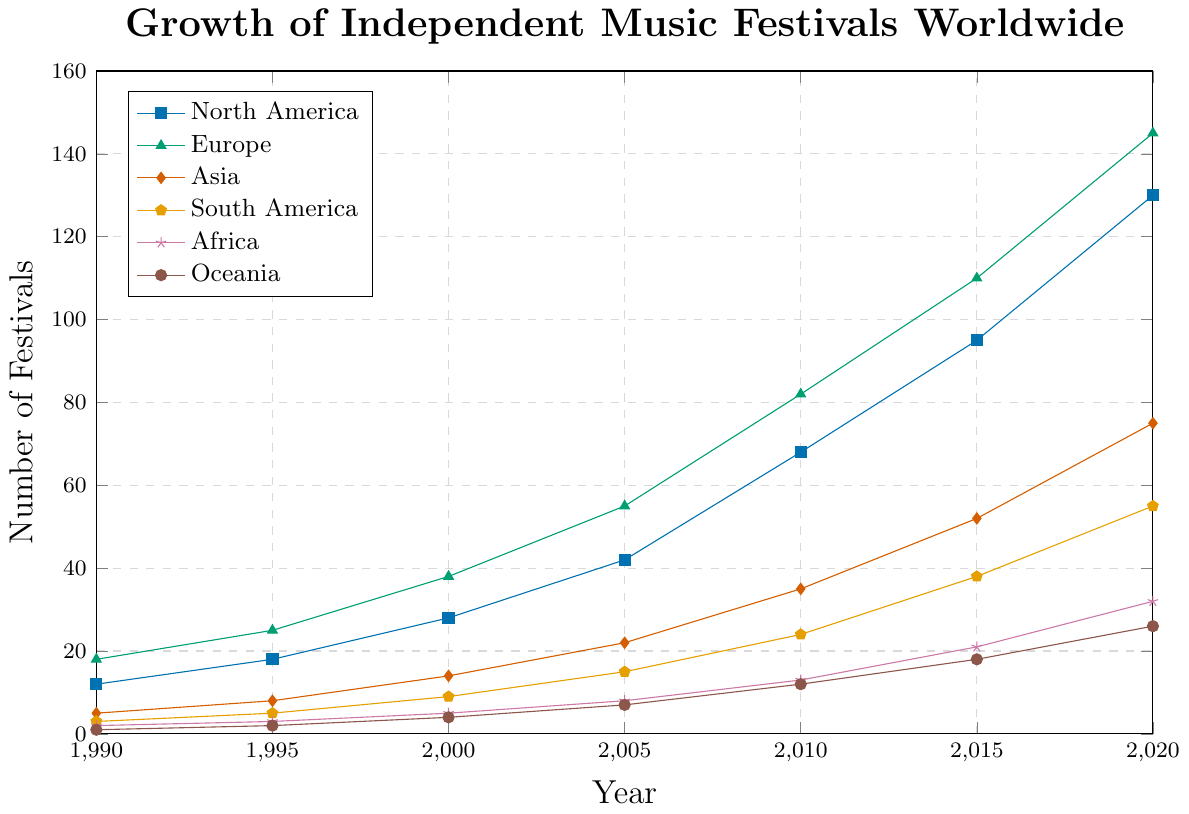How many music festivals were there in Oceania in 2000? Look at the data point for Oceania in the year 2000, which shows 4 festivals.
Answer: 4 Which continent had the highest number of music festivals in 2020? Observe the data points for the year 2020 across all continents; Europe has the highest with 145 festivals.
Answer: Europe Did the number of music festivals in Africa surpass 20 before 2015? Check the values for Africa across the years before 2015, which are 2, 3, 5, 8, and 13; none surpass 20.
Answer: No Which continent showed the fastest growth in music festivals between 1990 to 2020? Calculate the increase over the years for each continent: North America (118), Europe (127), Asia (70), South America (52), Africa (30), Oceania (25). Europe has the largest increase.
Answer: Europe What is the difference in the number of music festivals between North America and South America in 2010? Check the values for 2010 for both continents: North America (68), South America (24). The difference is 68 - 24 = 44.
Answer: 44 By how much did the number of music festivals in Asia increase from 1990 to 2000? Subtract the value of Asia in 1990 (5) from its value in 2000 (14); the increase is 14 - 5 = 9.
Answer: 9 In 2015, which two continents had nearly the same number of music festivals? Look for similar values in 2015: Africa (21) and Oceania (18) are quite close.
Answer: Africa and Oceania What is the average number of music festivals in Europe from 1990 to 2020? Sum the values for Europe (18 + 25 + 38 + 55 + 82 + 110 + 145 = 473) and divide by the number of data points (7). So, 473 / 7 ≈ 67.57.
Answer: 67.57 Which continent had the smallest increase in music festivals between 1990 and 2020? Calculate the increase: Oceania (25), North America (118), Europe (127), Asia (70), South America (52), Africa (30); Oceania has the smallest increase of 25.
Answer: Oceania In what year did South America surpass 30 music festivals? Track the data values for South America per year: 2015 is the first year South America achieves 38, surpassing 30.
Answer: 2015 